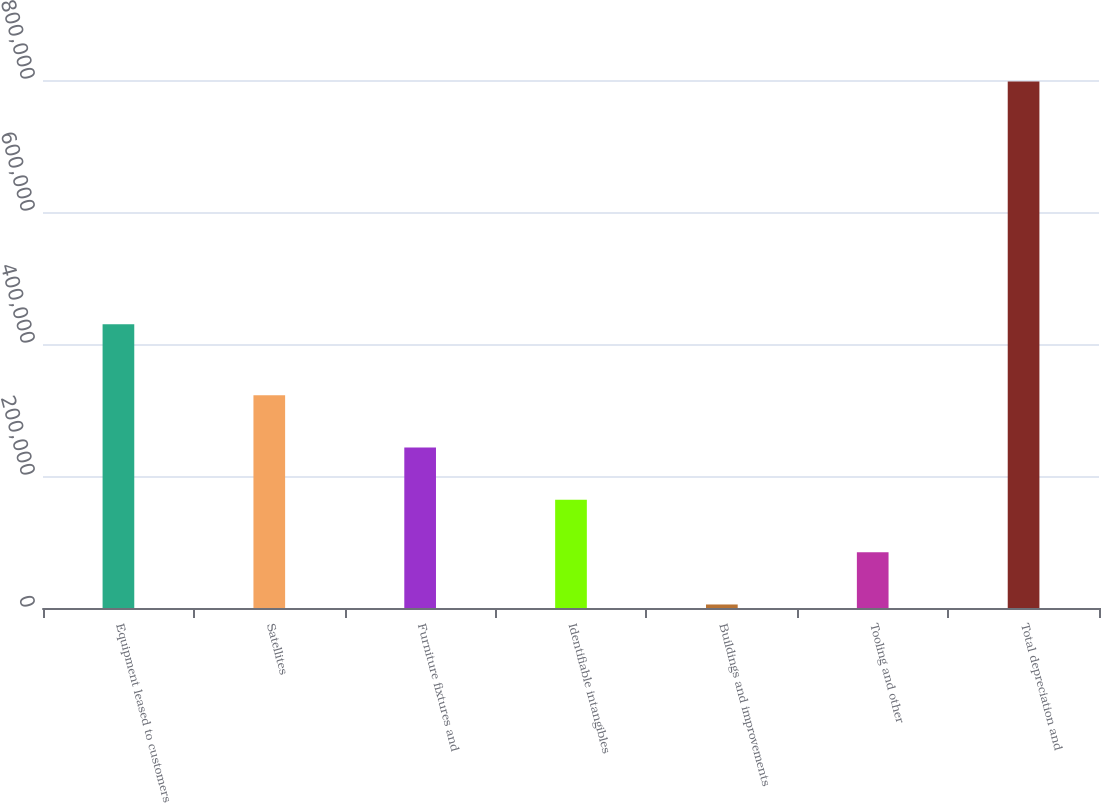Convert chart to OTSL. <chart><loc_0><loc_0><loc_500><loc_500><bar_chart><fcel>Equipment leased to customers<fcel>Satellites<fcel>Furniture fixtures and<fcel>Identifiable intangibles<fcel>Buildings and improvements<fcel>Tooling and other<fcel>Total depreciation and<nl><fcel>429906<fcel>322355<fcel>243099<fcel>163843<fcel>5331<fcel>84587.1<fcel>797892<nl></chart> 